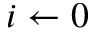Convert formula to latex. <formula><loc_0><loc_0><loc_500><loc_500>i \leftarrow 0</formula> 